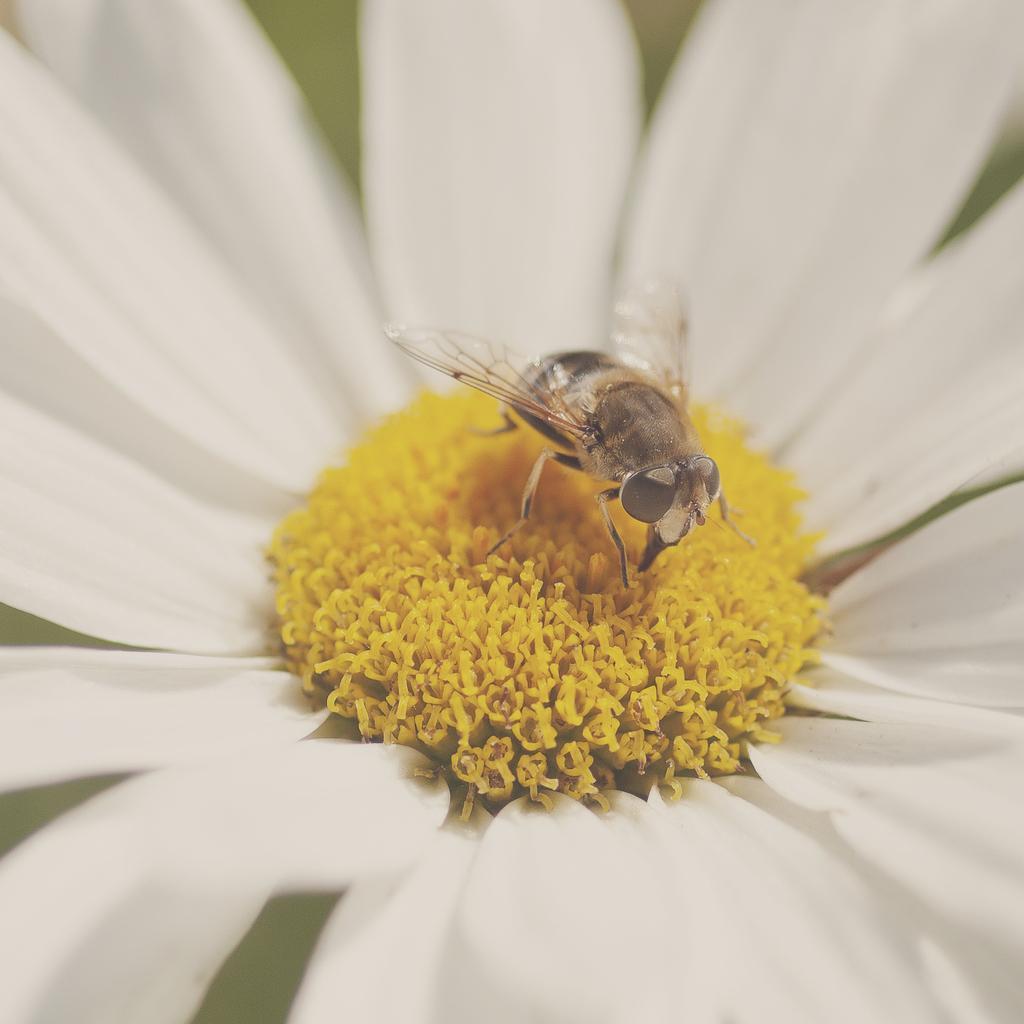Could you give a brief overview of what you see in this image? In this picture there is an insect on the white color flower. At the back there's a light green background. 